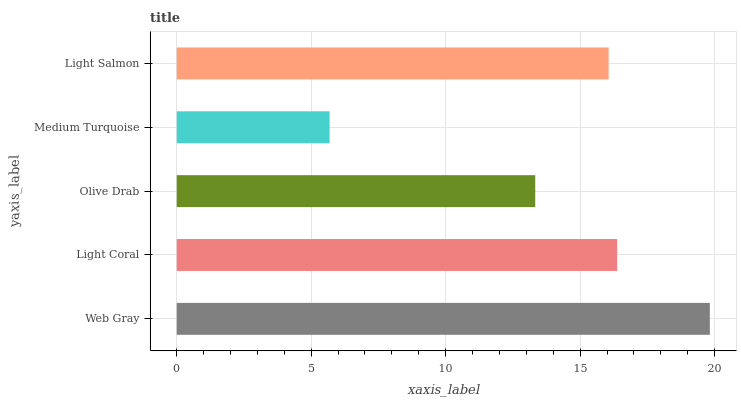Is Medium Turquoise the minimum?
Answer yes or no. Yes. Is Web Gray the maximum?
Answer yes or no. Yes. Is Light Coral the minimum?
Answer yes or no. No. Is Light Coral the maximum?
Answer yes or no. No. Is Web Gray greater than Light Coral?
Answer yes or no. Yes. Is Light Coral less than Web Gray?
Answer yes or no. Yes. Is Light Coral greater than Web Gray?
Answer yes or no. No. Is Web Gray less than Light Coral?
Answer yes or no. No. Is Light Salmon the high median?
Answer yes or no. Yes. Is Light Salmon the low median?
Answer yes or no. Yes. Is Web Gray the high median?
Answer yes or no. No. Is Medium Turquoise the low median?
Answer yes or no. No. 